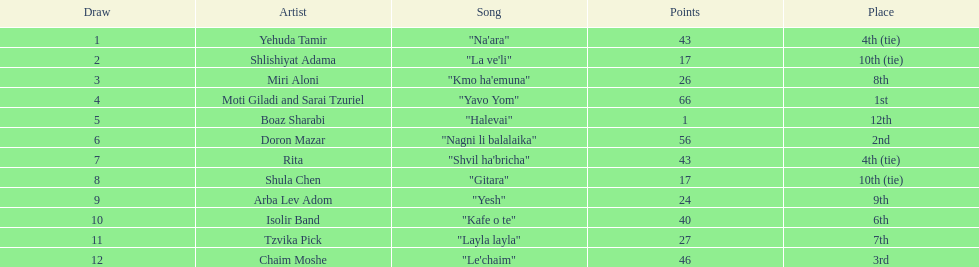How many points does the artist rita have? 43. 